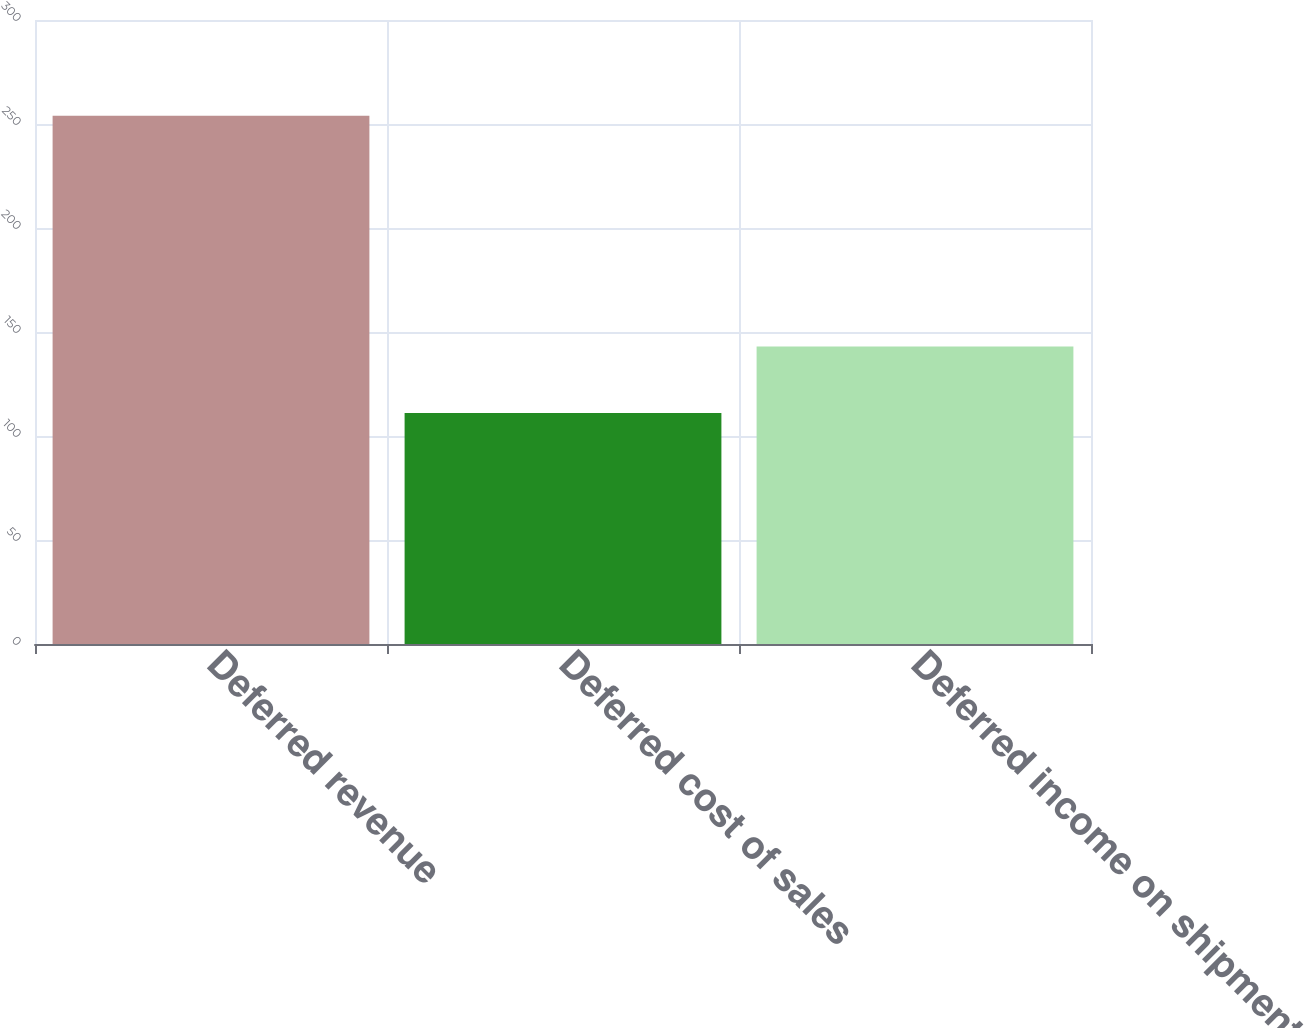Convert chart. <chart><loc_0><loc_0><loc_500><loc_500><bar_chart><fcel>Deferred revenue<fcel>Deferred cost of sales<fcel>Deferred income on shipments<nl><fcel>254<fcel>111<fcel>143<nl></chart> 